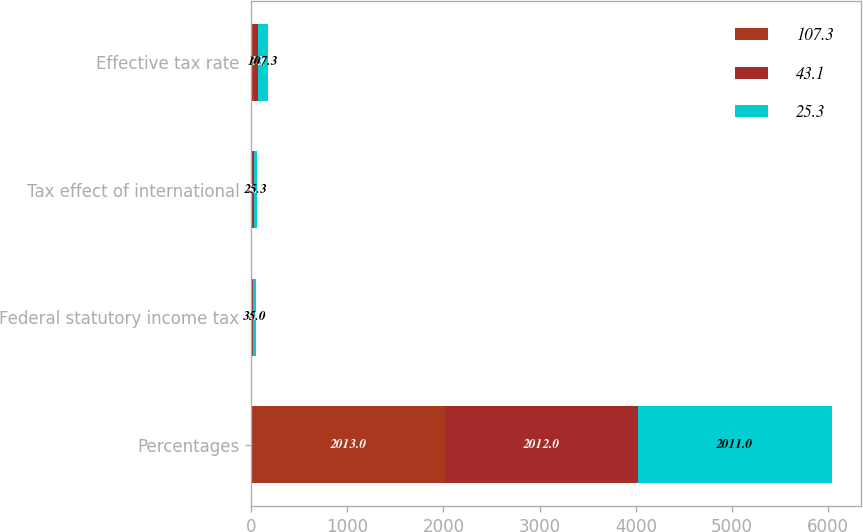Convert chart to OTSL. <chart><loc_0><loc_0><loc_500><loc_500><stacked_bar_chart><ecel><fcel>Percentages<fcel>Federal statutory income tax<fcel>Tax effect of international<fcel>Effective tax rate<nl><fcel>107.3<fcel>2013<fcel>7.8<fcel>10.5<fcel>25.3<nl><fcel>43.1<fcel>2012<fcel>7.8<fcel>23.6<fcel>43.1<nl><fcel>25.3<fcel>2011<fcel>35<fcel>25.3<fcel>107.3<nl></chart> 